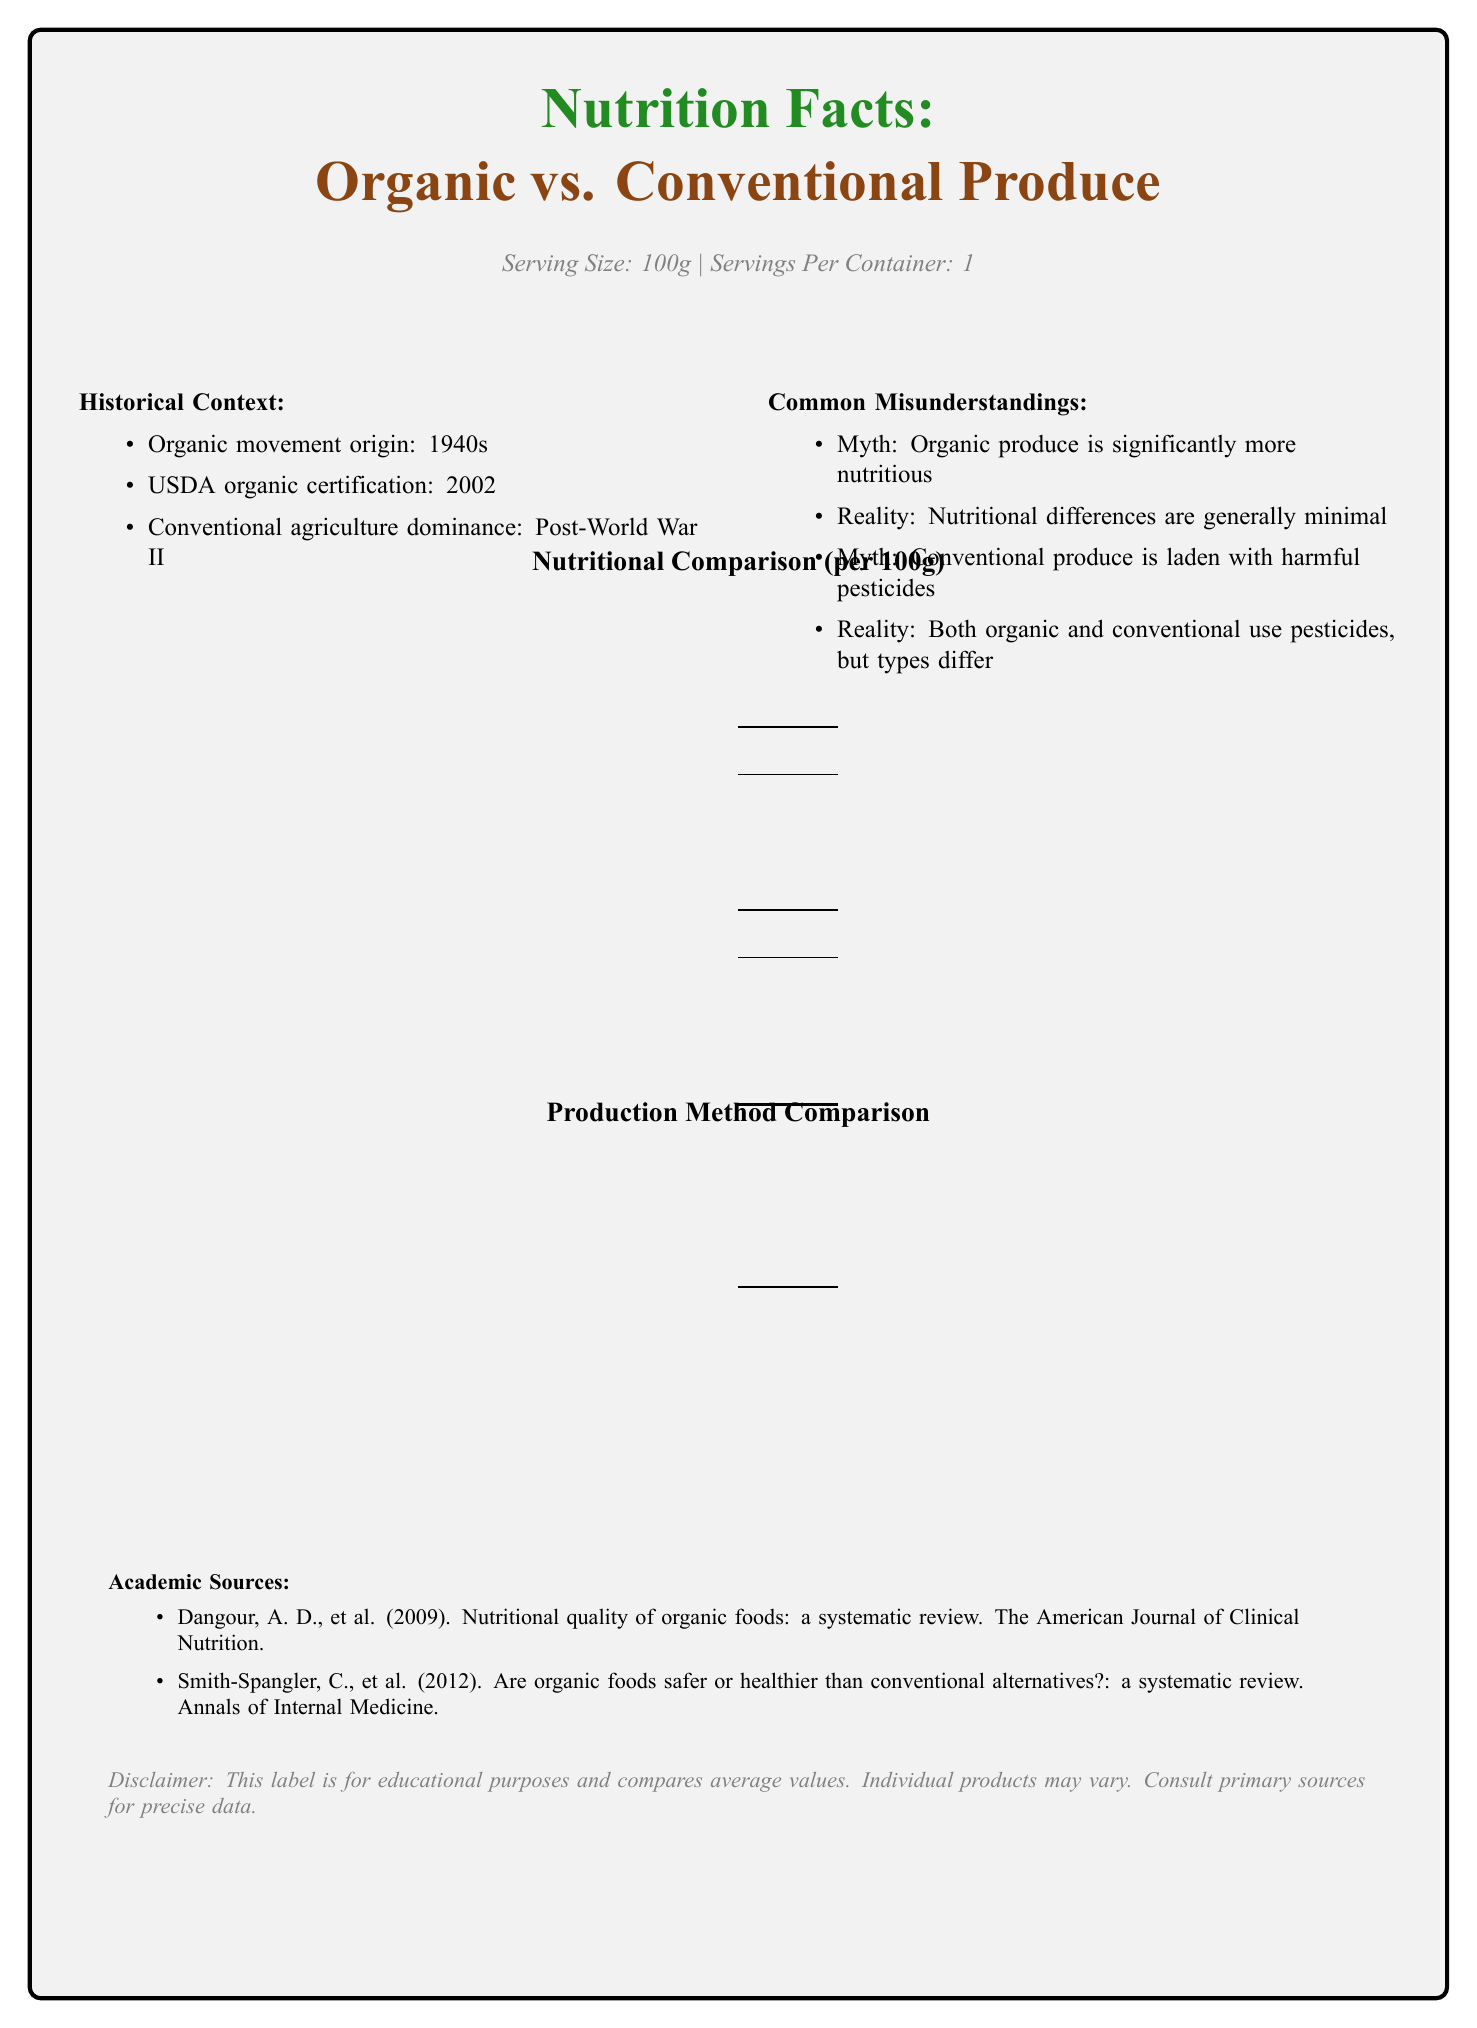what is the calorie content in organic produce? The document states that organic produce contains 45 calories per 100g.
Answer: 45 calories how much sodium does conventional produce contain? The label indicates that conventional produce has 6 mg of sodium per 100g.
Answer: 6 mg is there any trans fat in both organic and conventional produce? The nutritional comparison table shows that both organic and conventional produce have 0g of trans fat.
Answer: No how does the vitamin A content compare between organic and conventional produce? The comparison table shows that organic produce has 16% vitamin A, while conventional produce has 15%.
Answer: Organic produce has slightly more vitamin A (16%) compared to conventional produce (15%) which type of produce has higher dietary fiber content? Organic produce has 2.8g of dietary fiber, while conventional has 2.6g.
Answer: Organic what are the primary types of fertilizers used in organic farming? The production method comparison shows that these are the main fertilizers used in organic farming.
Answer: Compost, animal manure, and approved synthetic fertilizers compare the carbohydrate content of organic and conventional produce. A. Organic has more B. Conventional has more C. Both are equal The table states that organic produce has 11.2g of carbohydrates, while conventional produces has 11.8g.
Answer: B what does the historical context section say about the USDA organic certification? A. It originated in the 1940s B. It was introduced in 2002 C. It became dominant post-World War II The historical context mentions that the USDA organic certification began in 2002.
Answer: B true or false: genetic engineering is allowed in organic farming. The production method comparison table states that genetic engineering is not allowed in organic farming.
Answer: False summarize the main idea of the document. It is a comprehensive comparison of the nutritional values per 100g of organic vs. conventional produce, debunks common myths about organic and conventional farming, lists historical milestones in organic farming, and notes the different practices allowed in each method.
Answer: The document compares the nutritional content and production methods of organic and conventional produce, addressing common misunderstandings about food production methods, and provides historical context and academic references. what is the exact amount of vitamin C in organic produce? The document provides the percentage of the daily value (%DV) but does not specify the exact milligram quantity of vitamin C.
Answer: Not enough information what are the academic references provided in the document? The document lists these two academic sources at the bottom under the "Academic Sources" section.
Answer: Dangour, A. D., et al. (2009) in The American Journal of Clinical Nutrition and Smith-Spangler, C., et al. (2012) in Annals of Internal Medicine are organic produce significantly more nutritious than conventional produce? The document addresses this common misunderstanding by stating that nutritional differences are generally minimal.
Answer: No 